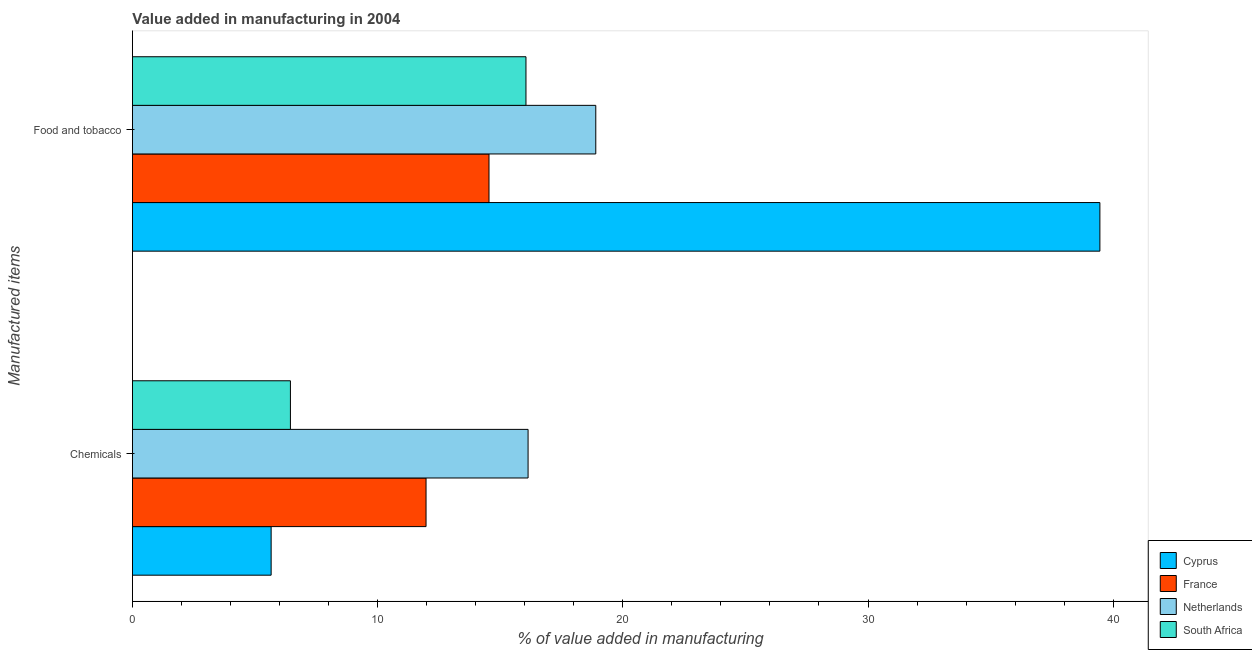How many different coloured bars are there?
Keep it short and to the point. 4. How many groups of bars are there?
Make the answer very short. 2. How many bars are there on the 2nd tick from the bottom?
Give a very brief answer. 4. What is the label of the 1st group of bars from the top?
Provide a succinct answer. Food and tobacco. What is the value added by manufacturing food and tobacco in South Africa?
Offer a very short reply. 16.05. Across all countries, what is the maximum value added by manufacturing food and tobacco?
Ensure brevity in your answer.  39.46. Across all countries, what is the minimum value added by  manufacturing chemicals?
Offer a very short reply. 5.66. In which country was the value added by  manufacturing chemicals maximum?
Keep it short and to the point. Netherlands. In which country was the value added by  manufacturing chemicals minimum?
Offer a very short reply. Cyprus. What is the total value added by manufacturing food and tobacco in the graph?
Your response must be concise. 88.95. What is the difference between the value added by  manufacturing chemicals in South Africa and that in France?
Provide a succinct answer. -5.53. What is the difference between the value added by manufacturing food and tobacco in France and the value added by  manufacturing chemicals in South Africa?
Offer a terse response. 8.1. What is the average value added by manufacturing food and tobacco per country?
Give a very brief answer. 22.24. What is the difference between the value added by manufacturing food and tobacco and value added by  manufacturing chemicals in Netherlands?
Give a very brief answer. 2.76. What is the ratio of the value added by  manufacturing chemicals in South Africa to that in Netherlands?
Ensure brevity in your answer.  0.4. Is the value added by manufacturing food and tobacco in South Africa less than that in France?
Your answer should be very brief. No. In how many countries, is the value added by manufacturing food and tobacco greater than the average value added by manufacturing food and tobacco taken over all countries?
Provide a short and direct response. 1. What does the 3rd bar from the top in Food and tobacco represents?
Provide a short and direct response. France. How many countries are there in the graph?
Your response must be concise. 4. Are the values on the major ticks of X-axis written in scientific E-notation?
Give a very brief answer. No. Where does the legend appear in the graph?
Your answer should be very brief. Bottom right. How are the legend labels stacked?
Offer a terse response. Vertical. What is the title of the graph?
Your answer should be compact. Value added in manufacturing in 2004. Does "Turkey" appear as one of the legend labels in the graph?
Your answer should be compact. No. What is the label or title of the X-axis?
Offer a terse response. % of value added in manufacturing. What is the label or title of the Y-axis?
Your answer should be compact. Manufactured items. What is the % of value added in manufacturing in Cyprus in Chemicals?
Your answer should be compact. 5.66. What is the % of value added in manufacturing of France in Chemicals?
Offer a terse response. 11.97. What is the % of value added in manufacturing of Netherlands in Chemicals?
Give a very brief answer. 16.14. What is the % of value added in manufacturing of South Africa in Chemicals?
Offer a terse response. 6.44. What is the % of value added in manufacturing in Cyprus in Food and tobacco?
Offer a very short reply. 39.46. What is the % of value added in manufacturing of France in Food and tobacco?
Make the answer very short. 14.54. What is the % of value added in manufacturing of Netherlands in Food and tobacco?
Provide a short and direct response. 18.9. What is the % of value added in manufacturing of South Africa in Food and tobacco?
Give a very brief answer. 16.05. Across all Manufactured items, what is the maximum % of value added in manufacturing of Cyprus?
Keep it short and to the point. 39.46. Across all Manufactured items, what is the maximum % of value added in manufacturing of France?
Offer a terse response. 14.54. Across all Manufactured items, what is the maximum % of value added in manufacturing in Netherlands?
Ensure brevity in your answer.  18.9. Across all Manufactured items, what is the maximum % of value added in manufacturing in South Africa?
Make the answer very short. 16.05. Across all Manufactured items, what is the minimum % of value added in manufacturing in Cyprus?
Your answer should be very brief. 5.66. Across all Manufactured items, what is the minimum % of value added in manufacturing in France?
Provide a succinct answer. 11.97. Across all Manufactured items, what is the minimum % of value added in manufacturing in Netherlands?
Offer a terse response. 16.14. Across all Manufactured items, what is the minimum % of value added in manufacturing in South Africa?
Provide a short and direct response. 6.44. What is the total % of value added in manufacturing of Cyprus in the graph?
Ensure brevity in your answer.  45.11. What is the total % of value added in manufacturing of France in the graph?
Ensure brevity in your answer.  26.52. What is the total % of value added in manufacturing in Netherlands in the graph?
Give a very brief answer. 35.03. What is the total % of value added in manufacturing in South Africa in the graph?
Ensure brevity in your answer.  22.49. What is the difference between the % of value added in manufacturing of Cyprus in Chemicals and that in Food and tobacco?
Provide a short and direct response. -33.8. What is the difference between the % of value added in manufacturing in France in Chemicals and that in Food and tobacco?
Provide a succinct answer. -2.57. What is the difference between the % of value added in manufacturing of Netherlands in Chemicals and that in Food and tobacco?
Ensure brevity in your answer.  -2.76. What is the difference between the % of value added in manufacturing of South Africa in Chemicals and that in Food and tobacco?
Provide a short and direct response. -9.61. What is the difference between the % of value added in manufacturing of Cyprus in Chemicals and the % of value added in manufacturing of France in Food and tobacco?
Keep it short and to the point. -8.89. What is the difference between the % of value added in manufacturing in Cyprus in Chemicals and the % of value added in manufacturing in Netherlands in Food and tobacco?
Offer a very short reply. -13.24. What is the difference between the % of value added in manufacturing of Cyprus in Chemicals and the % of value added in manufacturing of South Africa in Food and tobacco?
Your answer should be compact. -10.39. What is the difference between the % of value added in manufacturing in France in Chemicals and the % of value added in manufacturing in Netherlands in Food and tobacco?
Your response must be concise. -6.92. What is the difference between the % of value added in manufacturing in France in Chemicals and the % of value added in manufacturing in South Africa in Food and tobacco?
Offer a very short reply. -4.08. What is the difference between the % of value added in manufacturing of Netherlands in Chemicals and the % of value added in manufacturing of South Africa in Food and tobacco?
Your answer should be very brief. 0.09. What is the average % of value added in manufacturing of Cyprus per Manufactured items?
Your response must be concise. 22.56. What is the average % of value added in manufacturing of France per Manufactured items?
Offer a terse response. 13.26. What is the average % of value added in manufacturing in Netherlands per Manufactured items?
Provide a succinct answer. 17.52. What is the average % of value added in manufacturing in South Africa per Manufactured items?
Provide a succinct answer. 11.25. What is the difference between the % of value added in manufacturing in Cyprus and % of value added in manufacturing in France in Chemicals?
Provide a short and direct response. -6.32. What is the difference between the % of value added in manufacturing in Cyprus and % of value added in manufacturing in Netherlands in Chemicals?
Keep it short and to the point. -10.48. What is the difference between the % of value added in manufacturing of Cyprus and % of value added in manufacturing of South Africa in Chemicals?
Your answer should be compact. -0.79. What is the difference between the % of value added in manufacturing in France and % of value added in manufacturing in Netherlands in Chemicals?
Ensure brevity in your answer.  -4.16. What is the difference between the % of value added in manufacturing of France and % of value added in manufacturing of South Africa in Chemicals?
Ensure brevity in your answer.  5.53. What is the difference between the % of value added in manufacturing in Netherlands and % of value added in manufacturing in South Africa in Chemicals?
Ensure brevity in your answer.  9.69. What is the difference between the % of value added in manufacturing in Cyprus and % of value added in manufacturing in France in Food and tobacco?
Provide a short and direct response. 24.91. What is the difference between the % of value added in manufacturing in Cyprus and % of value added in manufacturing in Netherlands in Food and tobacco?
Offer a very short reply. 20.56. What is the difference between the % of value added in manufacturing of Cyprus and % of value added in manufacturing of South Africa in Food and tobacco?
Offer a terse response. 23.41. What is the difference between the % of value added in manufacturing in France and % of value added in manufacturing in Netherlands in Food and tobacco?
Your answer should be compact. -4.36. What is the difference between the % of value added in manufacturing in France and % of value added in manufacturing in South Africa in Food and tobacco?
Offer a very short reply. -1.51. What is the difference between the % of value added in manufacturing in Netherlands and % of value added in manufacturing in South Africa in Food and tobacco?
Offer a terse response. 2.85. What is the ratio of the % of value added in manufacturing of Cyprus in Chemicals to that in Food and tobacco?
Your answer should be compact. 0.14. What is the ratio of the % of value added in manufacturing of France in Chemicals to that in Food and tobacco?
Provide a succinct answer. 0.82. What is the ratio of the % of value added in manufacturing of Netherlands in Chemicals to that in Food and tobacco?
Make the answer very short. 0.85. What is the ratio of the % of value added in manufacturing of South Africa in Chemicals to that in Food and tobacco?
Your answer should be very brief. 0.4. What is the difference between the highest and the second highest % of value added in manufacturing in Cyprus?
Provide a short and direct response. 33.8. What is the difference between the highest and the second highest % of value added in manufacturing in France?
Your answer should be very brief. 2.57. What is the difference between the highest and the second highest % of value added in manufacturing of Netherlands?
Your response must be concise. 2.76. What is the difference between the highest and the second highest % of value added in manufacturing in South Africa?
Give a very brief answer. 9.61. What is the difference between the highest and the lowest % of value added in manufacturing in Cyprus?
Offer a terse response. 33.8. What is the difference between the highest and the lowest % of value added in manufacturing of France?
Your response must be concise. 2.57. What is the difference between the highest and the lowest % of value added in manufacturing of Netherlands?
Make the answer very short. 2.76. What is the difference between the highest and the lowest % of value added in manufacturing of South Africa?
Give a very brief answer. 9.61. 